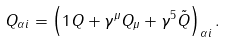<formula> <loc_0><loc_0><loc_500><loc_500>Q _ { \alpha i } = \left ( 1 Q + \gamma ^ { \mu } Q _ { \mu } + \gamma ^ { 5 } \tilde { Q } \right ) _ { \alpha i } .</formula> 